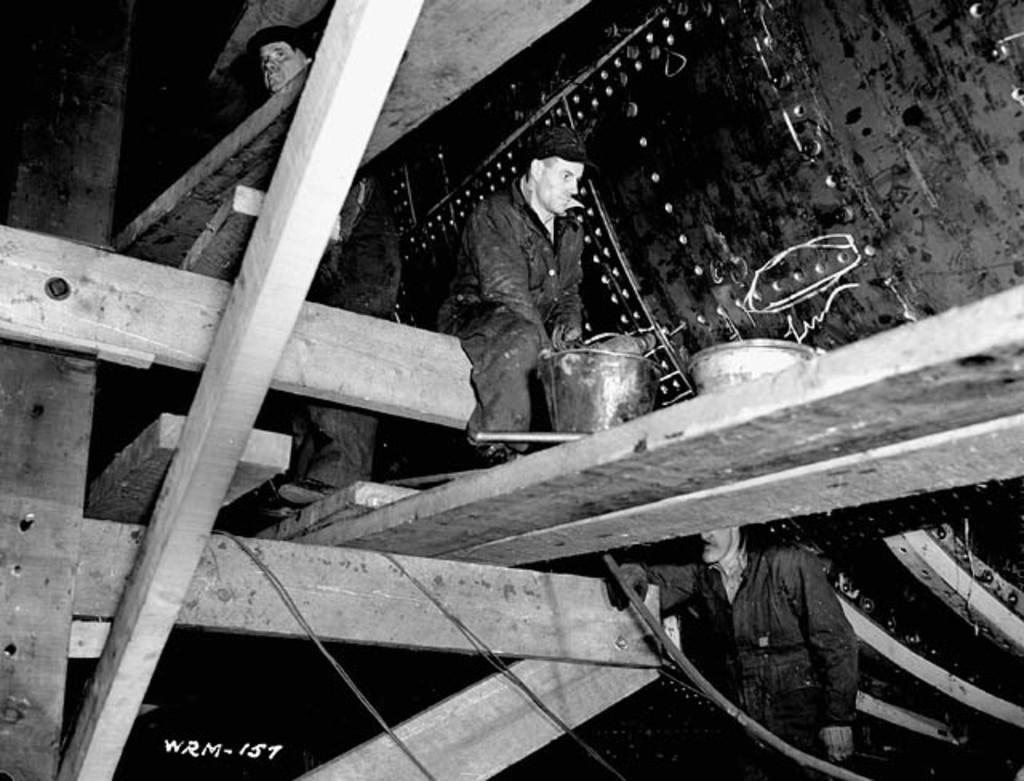What is the man in the image doing? There is a man sitting on a wooden log in the image. What is in front of the man sitting on the wooden log? There is a bucket in front of the man sitting on the wooden log. Can you describe the other person in the image? There is another man standing at the back in the image. What else can be seen in the image? There are wires visible in the image. What is the color scheme of the image? The image is in black and white. Can you tell me how many hydrants are visible in the image? There are no hydrants present in the image. What type of nest can be seen in the image? There is no nest present in the image. 